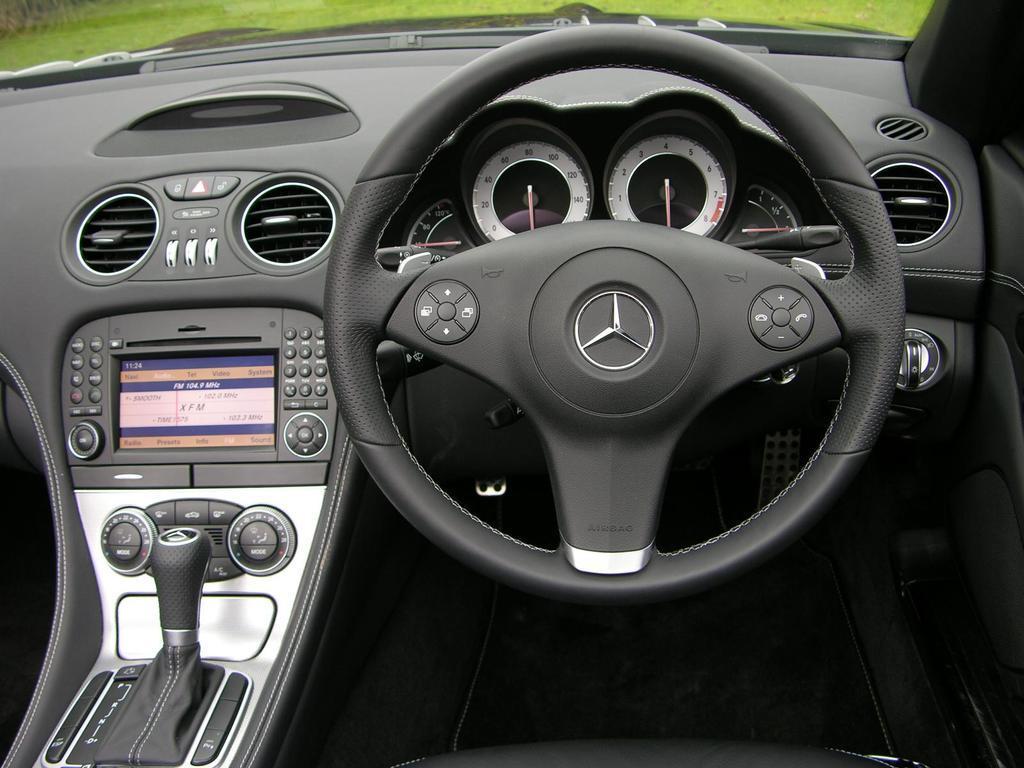Could you give a brief overview of what you see in this image? The picture is taken inside a car. This is a steering wheel. There are some meters. Some keys are here. Through the glass we can see outside grassland. 